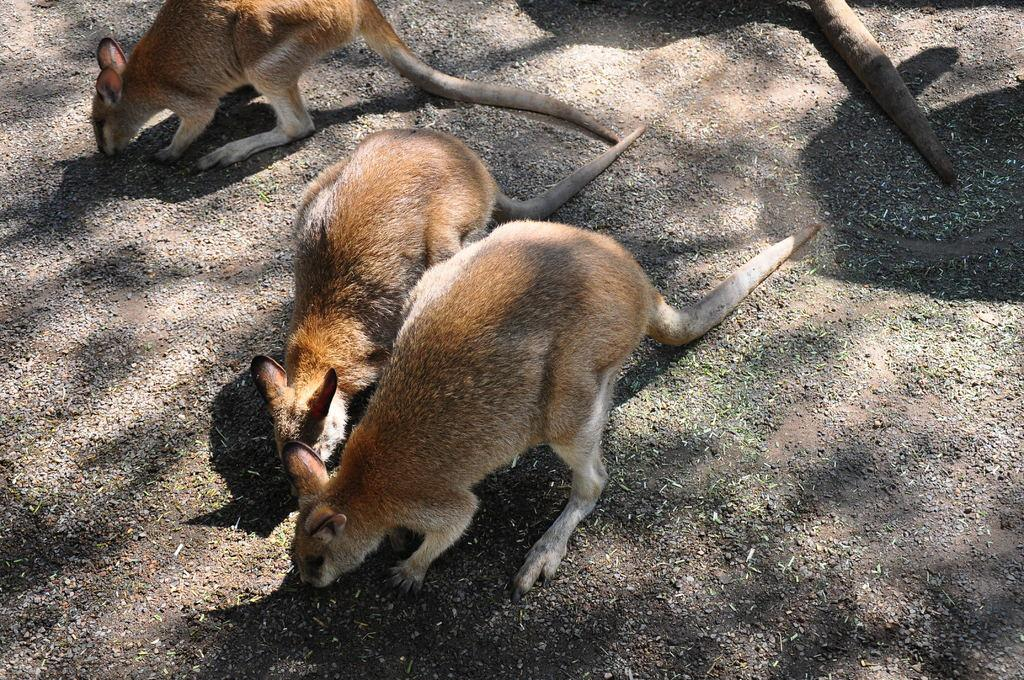What types of living organisms can be seen in the image? There are animals in the image. What is visible at the bottom of the image? Ground is visible at the bottom of the image. What type of apparel is the animal wearing in the image? There is no indication in the image that the animals are wearing any apparel. 